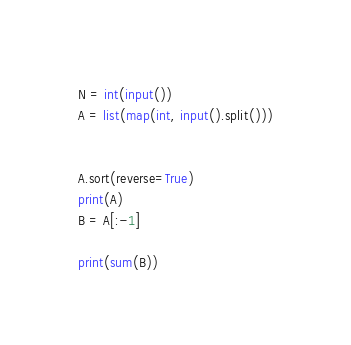Convert code to text. <code><loc_0><loc_0><loc_500><loc_500><_Python_>N = int(input())
A = list(map(int, input().split()))


A.sort(reverse=True)
print(A)
B = A[:-1]

print(sum(B))</code> 